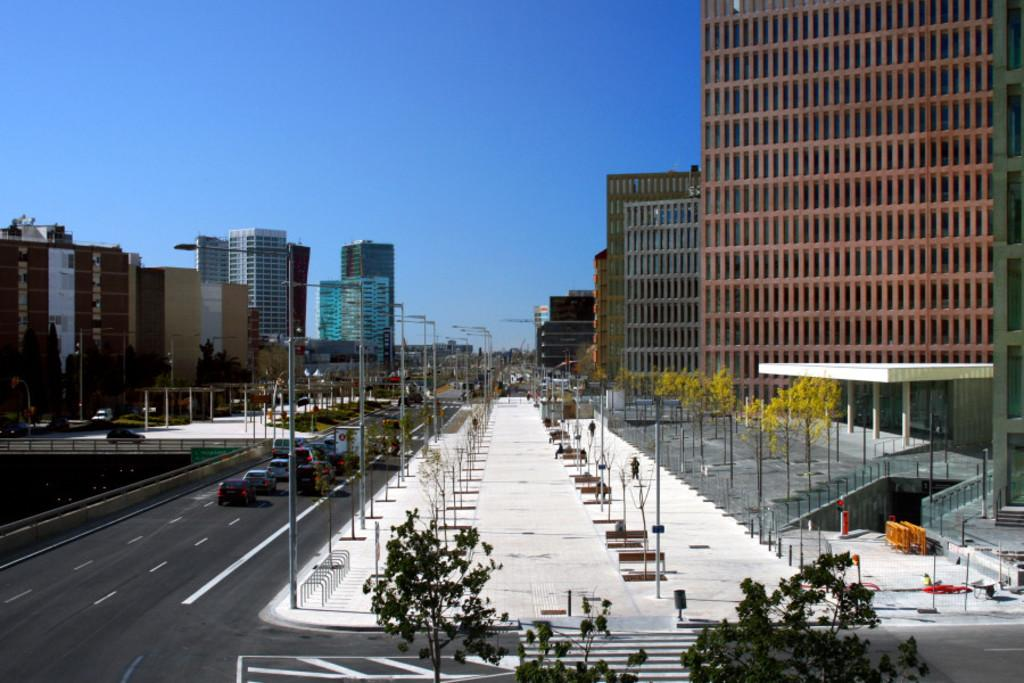What type of vegetation can be seen in the image? There are trees in the image. What structures are present in the image? There are poles with lights and buildings in the image. What is happening on the road in the image? There are vehicles on the road in the image. What can be seen in the background of the image? There are trees, buildings, and the sky visible in the background of the image. How many apples are hanging from the trees in the image? There are no apples visible in the image; only trees are present. What is the woman doing in the image? There is no woman present in the image. 